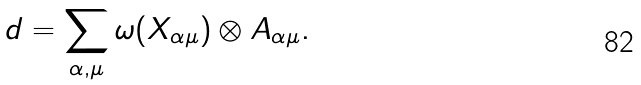Convert formula to latex. <formula><loc_0><loc_0><loc_500><loc_500>d = \sum _ { \alpha , \mu } \omega ( X _ { \alpha \mu } ) \otimes A _ { \alpha \mu } .</formula> 